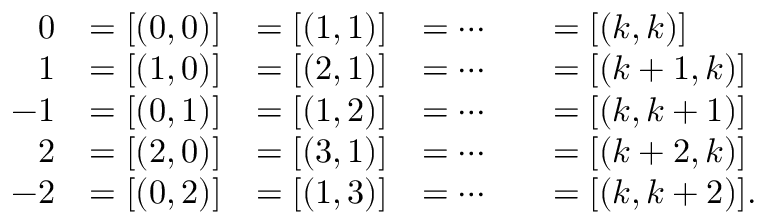<formula> <loc_0><loc_0><loc_500><loc_500>{ \begin{array} { r l r l r l } { 0 } & { = [ ( 0 , 0 ) ] } & { = [ ( 1 , 1 ) ] } & { = \cdots } & & { = [ ( k , k ) ] } \\ { 1 } & { = [ ( 1 , 0 ) ] } & { = [ ( 2 , 1 ) ] } & { = \cdots } & & { = [ ( k + 1 , k ) ] } \\ { - 1 } & { = [ ( 0 , 1 ) ] } & { = [ ( 1 , 2 ) ] } & { = \cdots } & & { = [ ( k , k + 1 ) ] } \\ { 2 } & { = [ ( 2 , 0 ) ] } & { = [ ( 3 , 1 ) ] } & { = \cdots } & & { = [ ( k + 2 , k ) ] } \\ { - 2 } & { = [ ( 0 , 2 ) ] } & { = [ ( 1 , 3 ) ] } & { = \cdots } & & { = [ ( k , k + 2 ) ] . } \end{array} }</formula> 